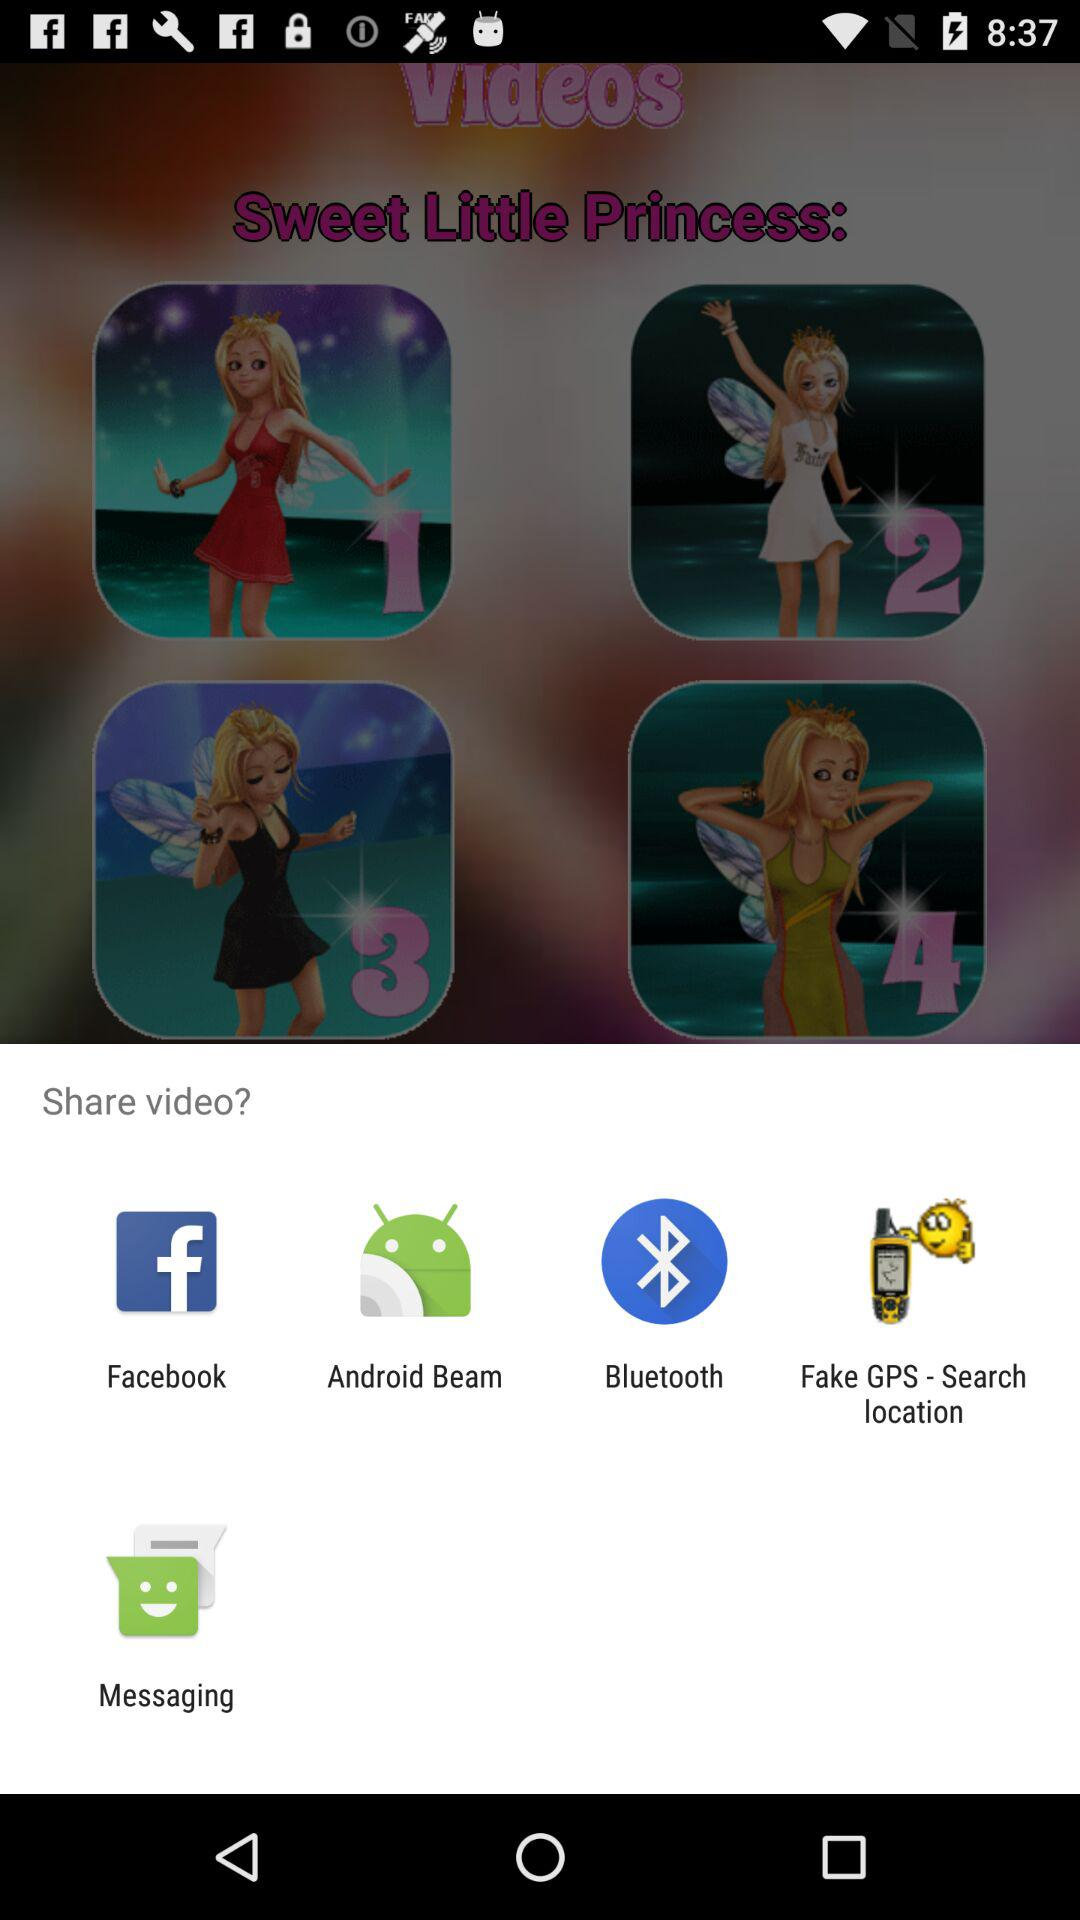Through what app can I share videos? You can share it with Facebook, Android Beam, Bluetooth, Fake GPS - Search location and Messaging. 